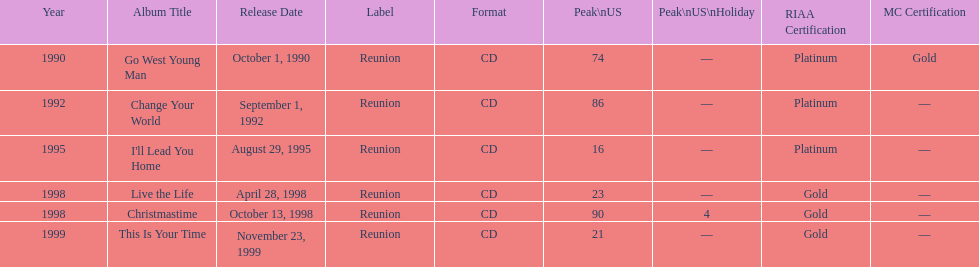What year comes after 1995? 1998. 